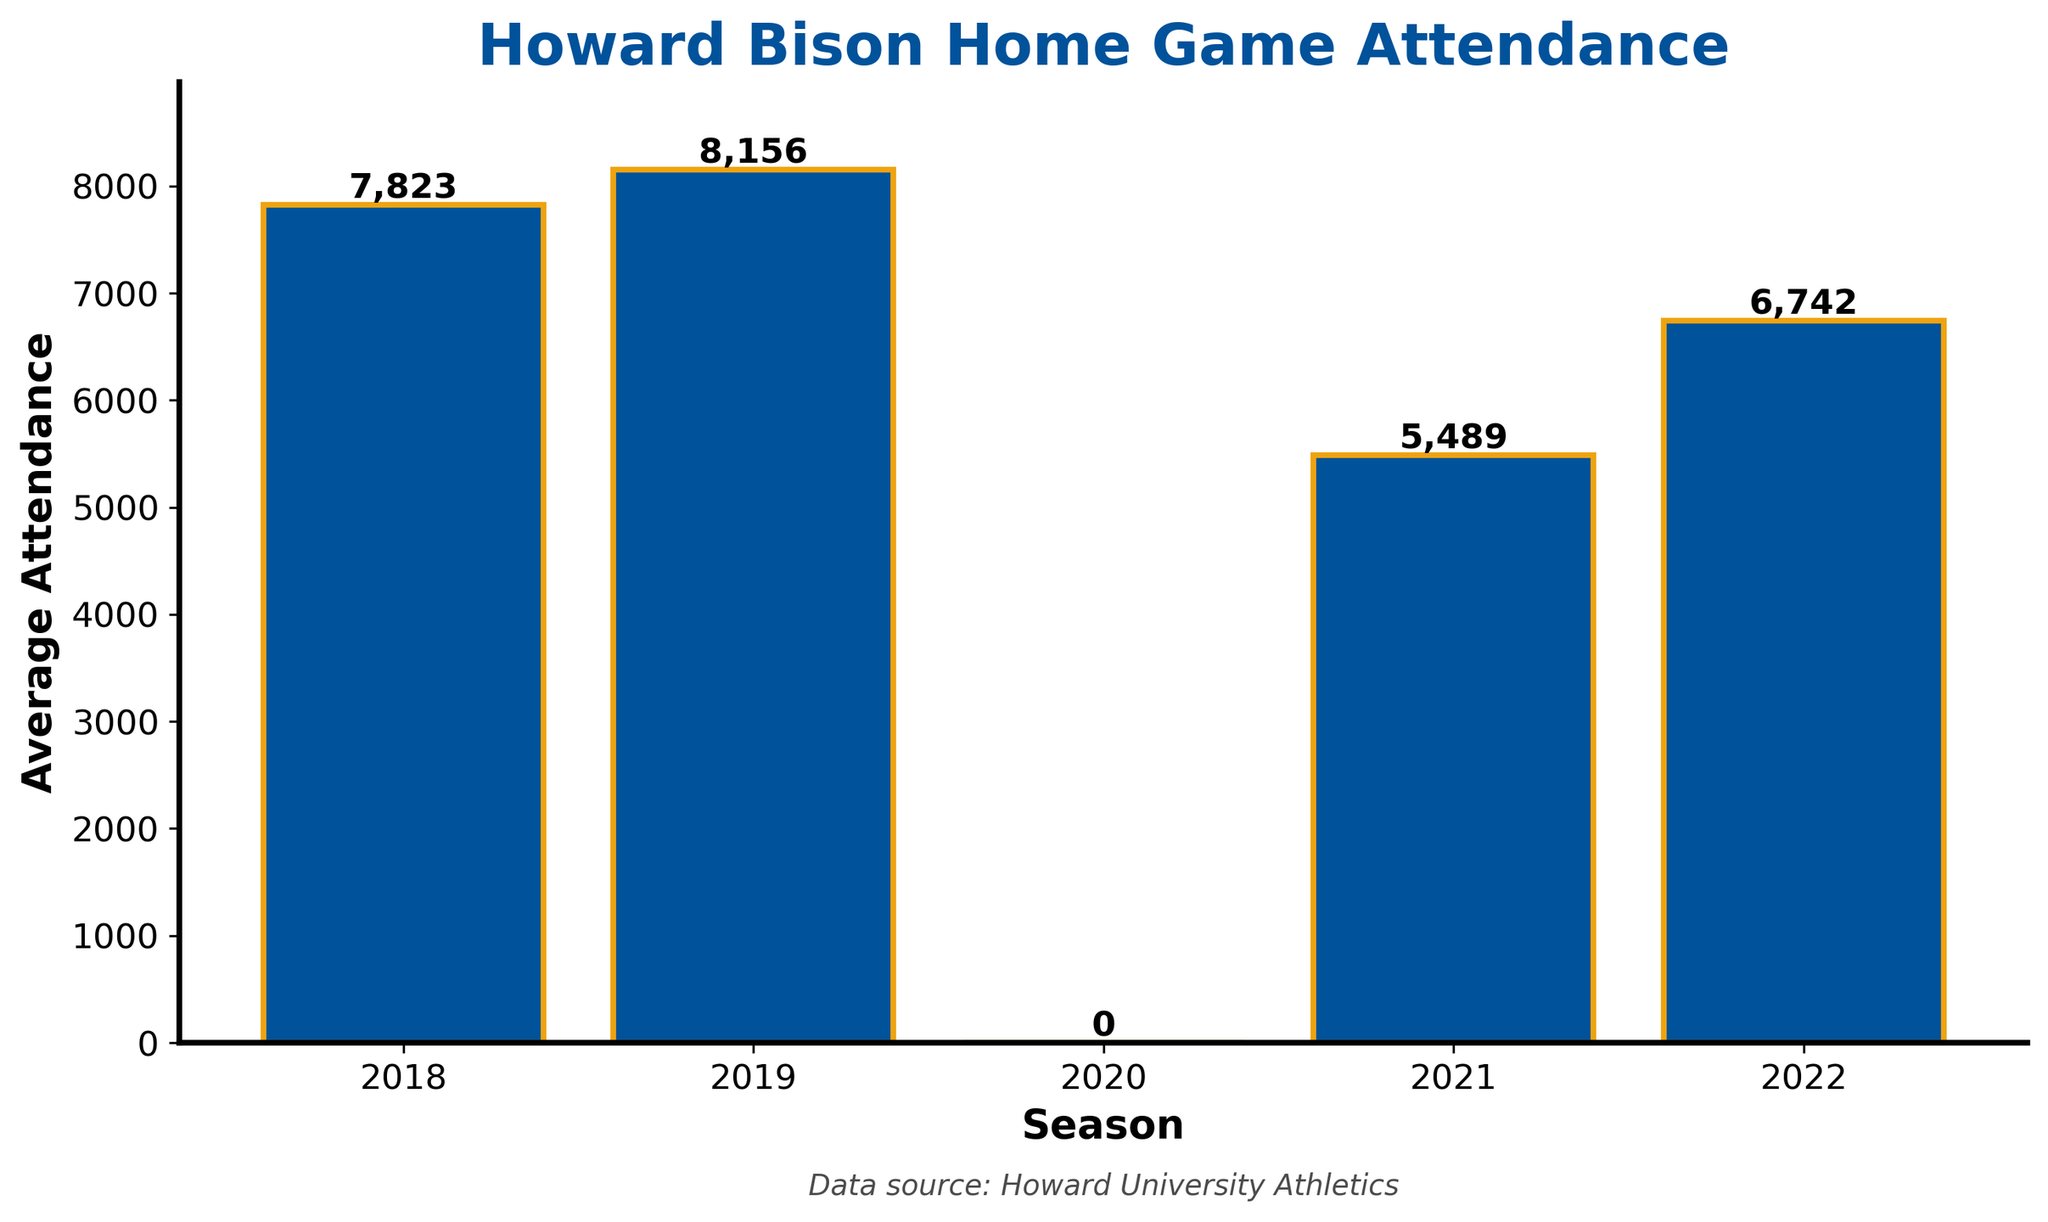what's the trend in average attendance from 2018 to 2022? To determine the trend, observe the heights of the bars from left to right (chronologically). From 2018 to 2019, the attendance increases, then it drops to zero in 2020, followed by a significant drop in 2021, and finally, it rises again in 2022.
Answer: Average attendance first increased, dropped to zero, then decreased, and finally increased again which season had the highest average attendance? Identify the tallest bar among the bars for each season, which represents the highest value. The bar for 2019 is the tallest.
Answer: 2019 what caused the average attendance to be zero in 2020? Looking at the bar, the value for 2020 is zero. This indicates no attendance. Infer historical reasons like the COVID-19 pandemic that led to cancellations of live events.
Answer: Likely COVID-19 pandemic what's the difference in average attendance between 2019 and 2021? Compare the height of the bars for 2019 and 2021. The 2019 bar represents an attendance of 8156, and the 2021 bar represents 5489. Calculate the difference: 8156 - 5489.
Answer: 2667 how did the average attendance change from 2021 to 2022? Compare the heights of the bars for 2021 and 2022. Notice the increase from 5489 in 2021 to 6742 in 2022.
Answer: Increased in which season did the average attendance have the lowest value (excluding the zero attendance)? Observe the bars to determine the lowest value bar, excluding the zero value in 2020. The lowest value is represented by the 2021 bar.
Answer: 2021 what's the sum of the average attendance over the five seasons? Add the average attendance values for all seasons: 7823 + 8156 + 0 + 5489 + 6742.
Answer: 28,210 which seasons had an average attendance greater than 7000? Identify the bars with heights representing values greater than 7000. The seasons corresponding to these bars are 2018 and 2019.
Answer: 2018 and 2019 how does the bar color and edge color help in making the chart visually distinct? Describe the visual attributes. The bars are colored in blue, which makes them stand out, and the edges are highlighted in orange, which adds definition and separation between individual bars.
Answer: Blue bars with orange edges enhance visibility what was the average attendance in 2018 and how does it compare to 2022? Look at the bar heights for 2018 and 2022. 2018 has an average attendance of 7823, while 2022 has 6742. Compare these values to see the difference: 7823 - 6742.
Answer: 1081 higher in 2018 